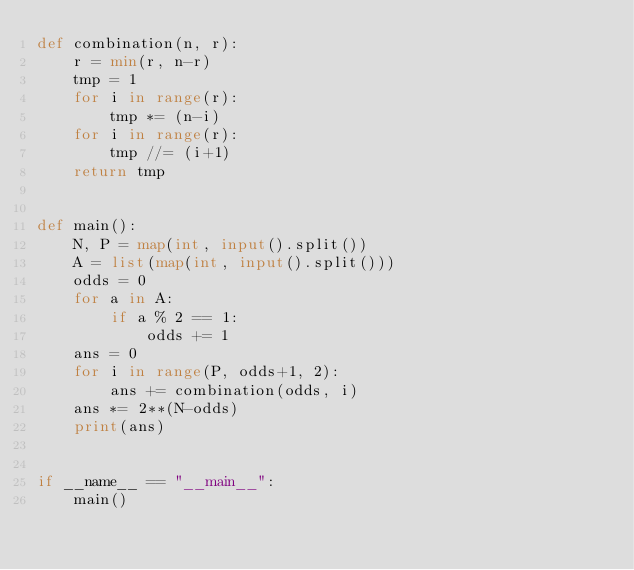Convert code to text. <code><loc_0><loc_0><loc_500><loc_500><_Python_>def combination(n, r):
    r = min(r, n-r)
    tmp = 1
    for i in range(r):
        tmp *= (n-i)
    for i in range(r):
        tmp //= (i+1)
    return tmp


def main():
    N, P = map(int, input().split())
    A = list(map(int, input().split()))
    odds = 0
    for a in A:
        if a % 2 == 1:
            odds += 1
    ans = 0
    for i in range(P, odds+1, 2):
        ans += combination(odds, i)
    ans *= 2**(N-odds)
    print(ans)


if __name__ == "__main__":
    main()
</code> 